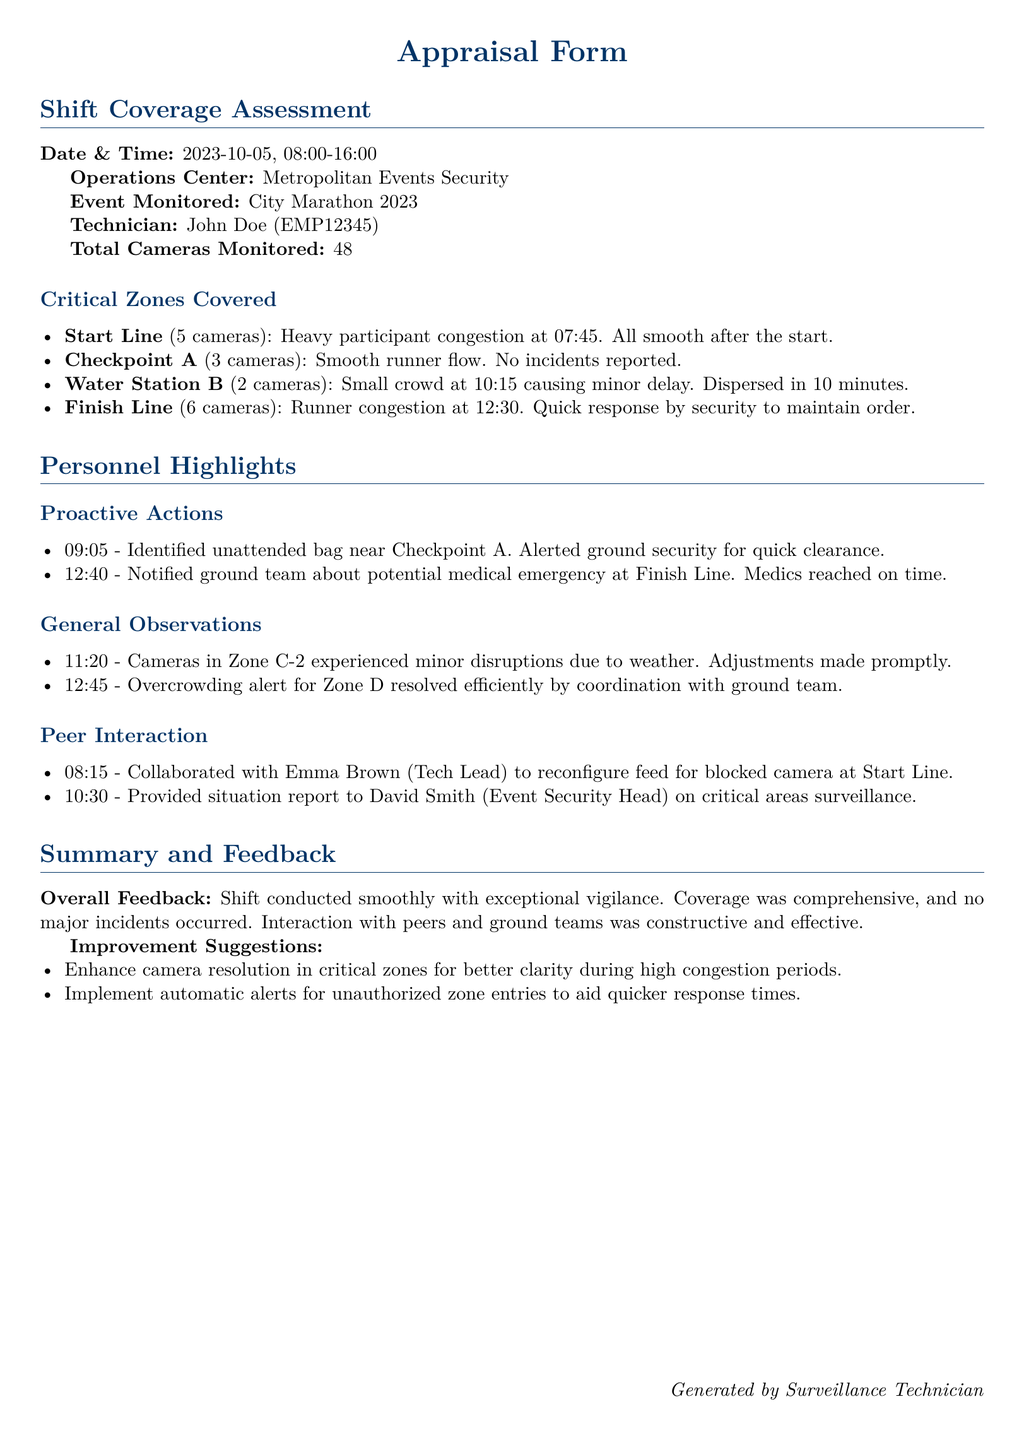What is the date and time of the shift? The date and time of the shift are specified in the document as the date and time format.
Answer: 2023-10-05, 08:00-16:00 Who was the technician on shift? The document lists the technician responsible for monitoring the cameras during the event.
Answer: John Doe (EMP12345) How many cameras were monitored in total? The total number of cameras monitored during the shift is clearly stated in the document.
Answer: 48 What was the major issue at the Finish Line? The document describes a specific incident at the Finish Line related to crowd control.
Answer: Runner congestion What time did the unattended bag get reported? A specific time for when the unattended bag was reported is noted in the proactive actions section.
Answer: 09:05 What suggestions were made for improvement? The document lists suggestions for enhancing future operations based on observations during the event.
Answer: Enhance camera resolution in critical zones Which zone experienced overcrowding? The document highlights a specific zone that had an overcrowding issue that needed resolution.
Answer: Zone D How many cameras were covering the Start Line? The number of cameras monitoring the Start Line is indicated in the critical zones covered section.
Answer: 5 cameras What response was taken for the medical emergency? The document describes a timely response by medics for a reported medical emergency.
Answer: Medics reached on time 